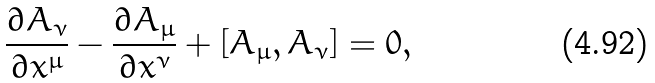<formula> <loc_0><loc_0><loc_500><loc_500>\frac { \partial A _ { \nu } } { \partial x ^ { \mu } } - \frac { \partial A _ { \mu } } { \partial x ^ { \nu } } + [ A _ { \mu } , A _ { \nu } ] = 0 ,</formula> 